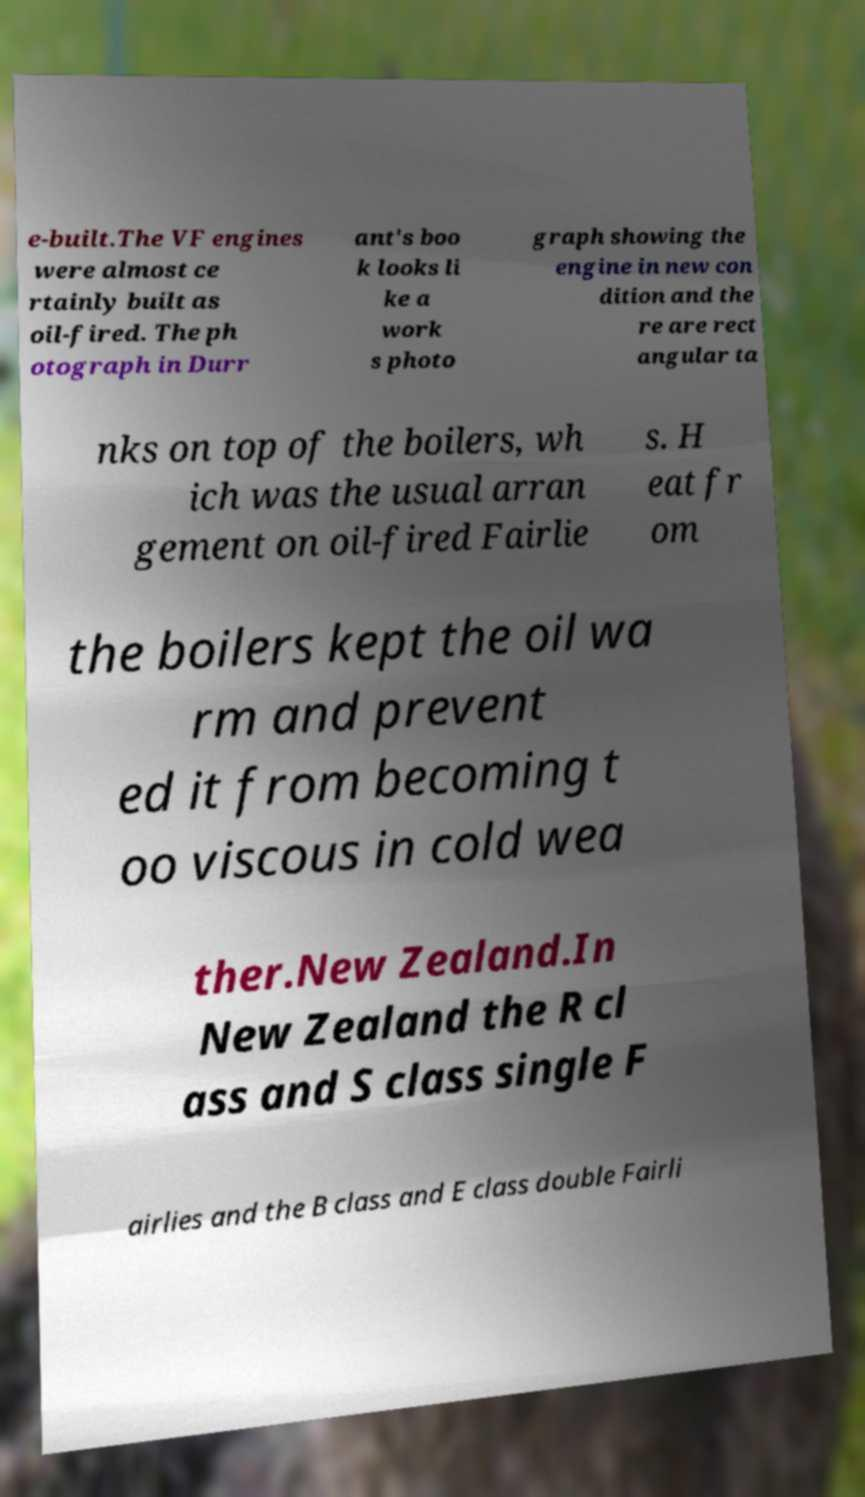Can you read and provide the text displayed in the image?This photo seems to have some interesting text. Can you extract and type it out for me? e-built.The VF engines were almost ce rtainly built as oil-fired. The ph otograph in Durr ant's boo k looks li ke a work s photo graph showing the engine in new con dition and the re are rect angular ta nks on top of the boilers, wh ich was the usual arran gement on oil-fired Fairlie s. H eat fr om the boilers kept the oil wa rm and prevent ed it from becoming t oo viscous in cold wea ther.New Zealand.In New Zealand the R cl ass and S class single F airlies and the B class and E class double Fairli 